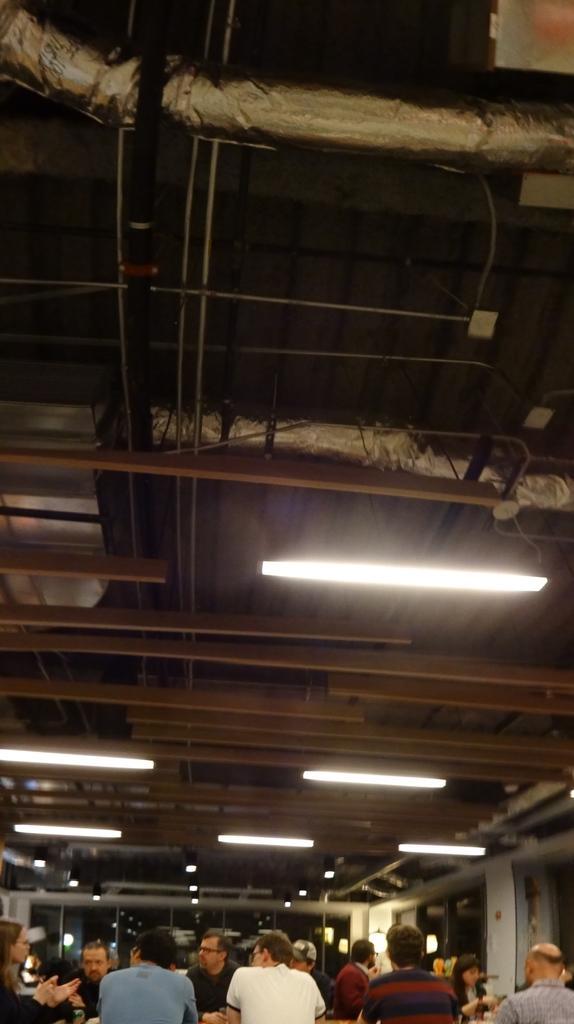In one or two sentences, can you explain what this image depicts? In this image, we can see some people, at the top there is a shed and we can see some lights. 